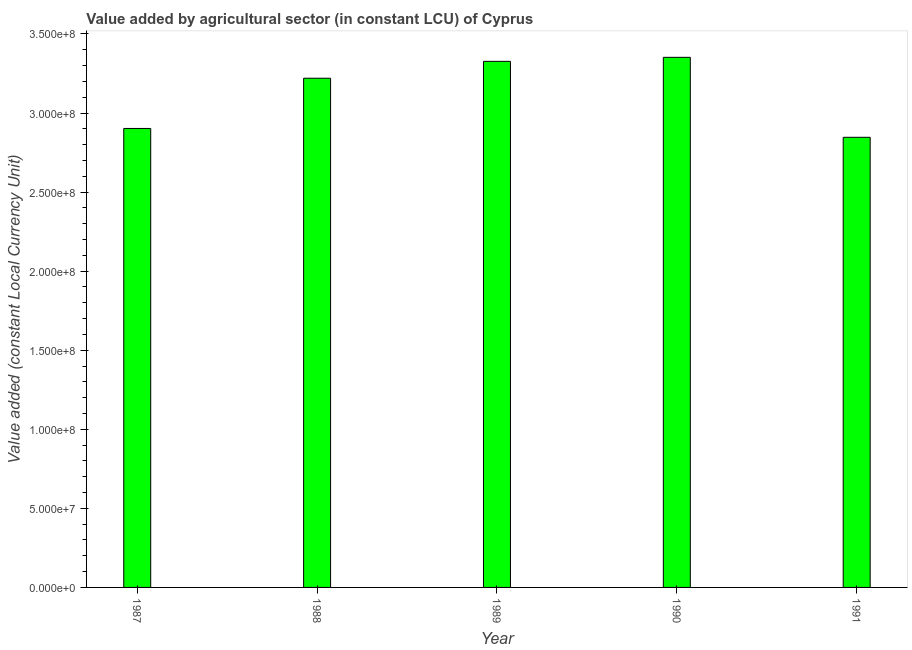Does the graph contain any zero values?
Ensure brevity in your answer.  No. What is the title of the graph?
Provide a short and direct response. Value added by agricultural sector (in constant LCU) of Cyprus. What is the label or title of the Y-axis?
Offer a very short reply. Value added (constant Local Currency Unit). What is the value added by agriculture sector in 1991?
Provide a short and direct response. 2.85e+08. Across all years, what is the maximum value added by agriculture sector?
Offer a very short reply. 3.35e+08. Across all years, what is the minimum value added by agriculture sector?
Give a very brief answer. 2.85e+08. In which year was the value added by agriculture sector minimum?
Your answer should be compact. 1991. What is the sum of the value added by agriculture sector?
Your answer should be compact. 1.56e+09. What is the difference between the value added by agriculture sector in 1987 and 1990?
Provide a succinct answer. -4.50e+07. What is the average value added by agriculture sector per year?
Your answer should be very brief. 3.13e+08. What is the median value added by agriculture sector?
Offer a terse response. 3.22e+08. Do a majority of the years between 1987 and 1988 (inclusive) have value added by agriculture sector greater than 130000000 LCU?
Make the answer very short. Yes. What is the ratio of the value added by agriculture sector in 1990 to that in 1991?
Your answer should be very brief. 1.18. Is the difference between the value added by agriculture sector in 1989 and 1990 greater than the difference between any two years?
Your response must be concise. No. What is the difference between the highest and the second highest value added by agriculture sector?
Your answer should be very brief. 2.54e+06. Is the sum of the value added by agriculture sector in 1990 and 1991 greater than the maximum value added by agriculture sector across all years?
Provide a short and direct response. Yes. What is the difference between the highest and the lowest value added by agriculture sector?
Offer a very short reply. 5.06e+07. How many bars are there?
Offer a terse response. 5. Are all the bars in the graph horizontal?
Offer a very short reply. No. How many years are there in the graph?
Your response must be concise. 5. What is the Value added (constant Local Currency Unit) of 1987?
Make the answer very short. 2.90e+08. What is the Value added (constant Local Currency Unit) in 1988?
Keep it short and to the point. 3.22e+08. What is the Value added (constant Local Currency Unit) in 1989?
Offer a very short reply. 3.33e+08. What is the Value added (constant Local Currency Unit) of 1990?
Your response must be concise. 3.35e+08. What is the Value added (constant Local Currency Unit) in 1991?
Provide a short and direct response. 2.85e+08. What is the difference between the Value added (constant Local Currency Unit) in 1987 and 1988?
Give a very brief answer. -3.18e+07. What is the difference between the Value added (constant Local Currency Unit) in 1987 and 1989?
Keep it short and to the point. -4.24e+07. What is the difference between the Value added (constant Local Currency Unit) in 1987 and 1990?
Provide a short and direct response. -4.50e+07. What is the difference between the Value added (constant Local Currency Unit) in 1987 and 1991?
Make the answer very short. 5.59e+06. What is the difference between the Value added (constant Local Currency Unit) in 1988 and 1989?
Your answer should be compact. -1.07e+07. What is the difference between the Value added (constant Local Currency Unit) in 1988 and 1990?
Provide a short and direct response. -1.32e+07. What is the difference between the Value added (constant Local Currency Unit) in 1988 and 1991?
Make the answer very short. 3.74e+07. What is the difference between the Value added (constant Local Currency Unit) in 1989 and 1990?
Provide a short and direct response. -2.54e+06. What is the difference between the Value added (constant Local Currency Unit) in 1989 and 1991?
Your response must be concise. 4.80e+07. What is the difference between the Value added (constant Local Currency Unit) in 1990 and 1991?
Provide a succinct answer. 5.06e+07. What is the ratio of the Value added (constant Local Currency Unit) in 1987 to that in 1988?
Offer a very short reply. 0.9. What is the ratio of the Value added (constant Local Currency Unit) in 1987 to that in 1989?
Make the answer very short. 0.87. What is the ratio of the Value added (constant Local Currency Unit) in 1987 to that in 1990?
Offer a terse response. 0.87. What is the ratio of the Value added (constant Local Currency Unit) in 1987 to that in 1991?
Offer a terse response. 1.02. What is the ratio of the Value added (constant Local Currency Unit) in 1988 to that in 1989?
Keep it short and to the point. 0.97. What is the ratio of the Value added (constant Local Currency Unit) in 1988 to that in 1990?
Provide a short and direct response. 0.96. What is the ratio of the Value added (constant Local Currency Unit) in 1988 to that in 1991?
Make the answer very short. 1.13. What is the ratio of the Value added (constant Local Currency Unit) in 1989 to that in 1990?
Give a very brief answer. 0.99. What is the ratio of the Value added (constant Local Currency Unit) in 1989 to that in 1991?
Offer a very short reply. 1.17. What is the ratio of the Value added (constant Local Currency Unit) in 1990 to that in 1991?
Offer a terse response. 1.18. 